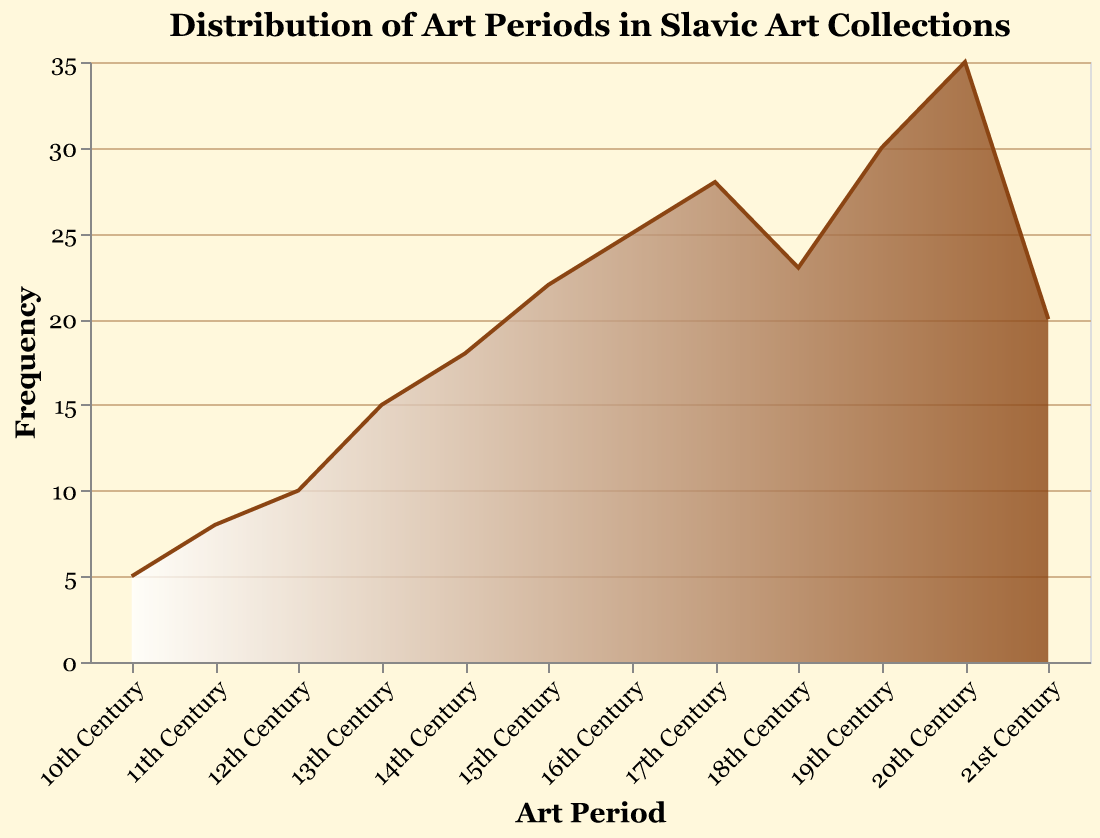What is the title of the figure? The title is usually located at the top of the figure. Here, it reads "Distribution of Art Periods in Slavic Art Collections."
Answer: Distribution of Art Periods in Slavic Art Collections Which art period has the highest frequency of Slavic art collections? By scanning the y-axis values, it's evident that the 20th Century has the highest frequency, with a value of 35.
Answer: 20th Century How many art periods have a frequency greater than 25? By examining the y-axis values, the 17th, 19th, and 20th Centuries have frequencies greater than 25. That's 3 periods.
Answer: 3 What's the frequency difference between the 13th Century and the 17th Century? The 13th Century has a frequency of 15, while the 17th Century has a frequency of 28. The difference is calculated as 28 - 15.
Answer: 13 Which century marks the start of an upward trend in frequency? By observing the trend of the figure, the upward trend starts from the 11th Century onwards.
Answer: 11th Century What is the average frequency across all art periods? The frequencies are: 5, 8, 10, 15, 18, 22, 25, 28, 23, 30, 35, and 20. Summing these gives 239, and there are 12 periods, so 239/12.
Answer: 19.92 Which art period has the lowest frequency? By inspecting the lower end of the y-axis, the 10th Century has the lowest frequency with a value of 5.
Answer: 10th Century What is the total frequency of Slavic art collections from the 18th to 21st centuries? Adding frequencies from the 18th Century (23), 19th Century (30), 20th Century (35), and 21st Century (20): 23 + 30 + 35 + 20.
Answer: 108 Between which two consecutive centuries is the largest frequency increase? Analyzing the differences between consecutive values reveals the largest increase between the 16th Century (25) and the 17th Century (28).
Answer: 16th and 17th Centuries 